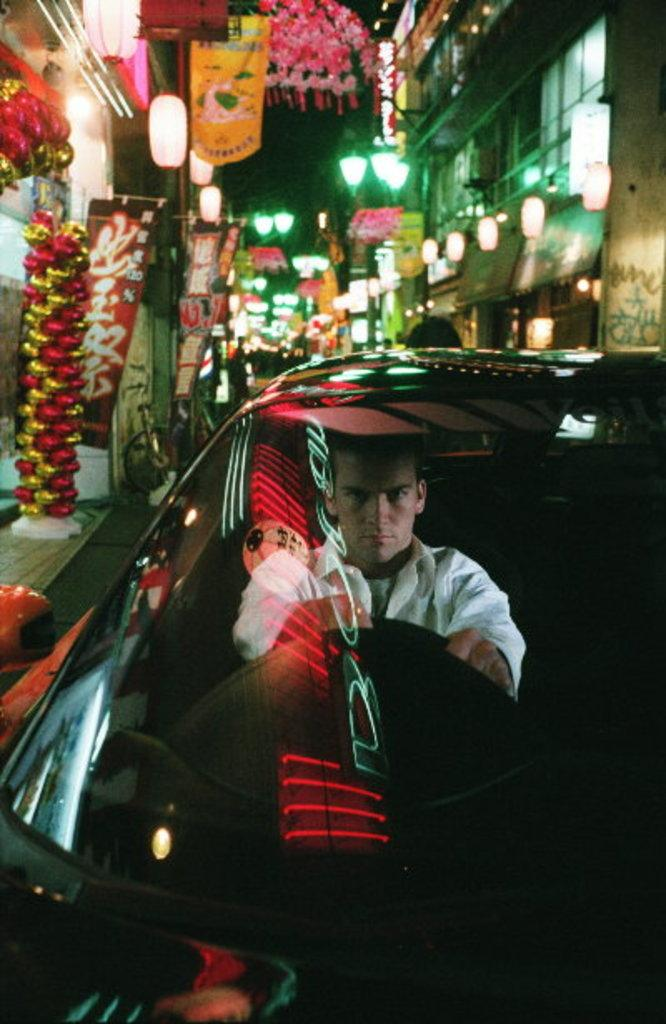What is the man doing in the image? There is a man riding a car in the image. What can be seen in the background of the image? There are decorative flowers, buildings, and lights in the background of the image. How many bears are sitting on the crate next to the mailbox in the image? There are no bears, crate, or mailbox present in the image. 